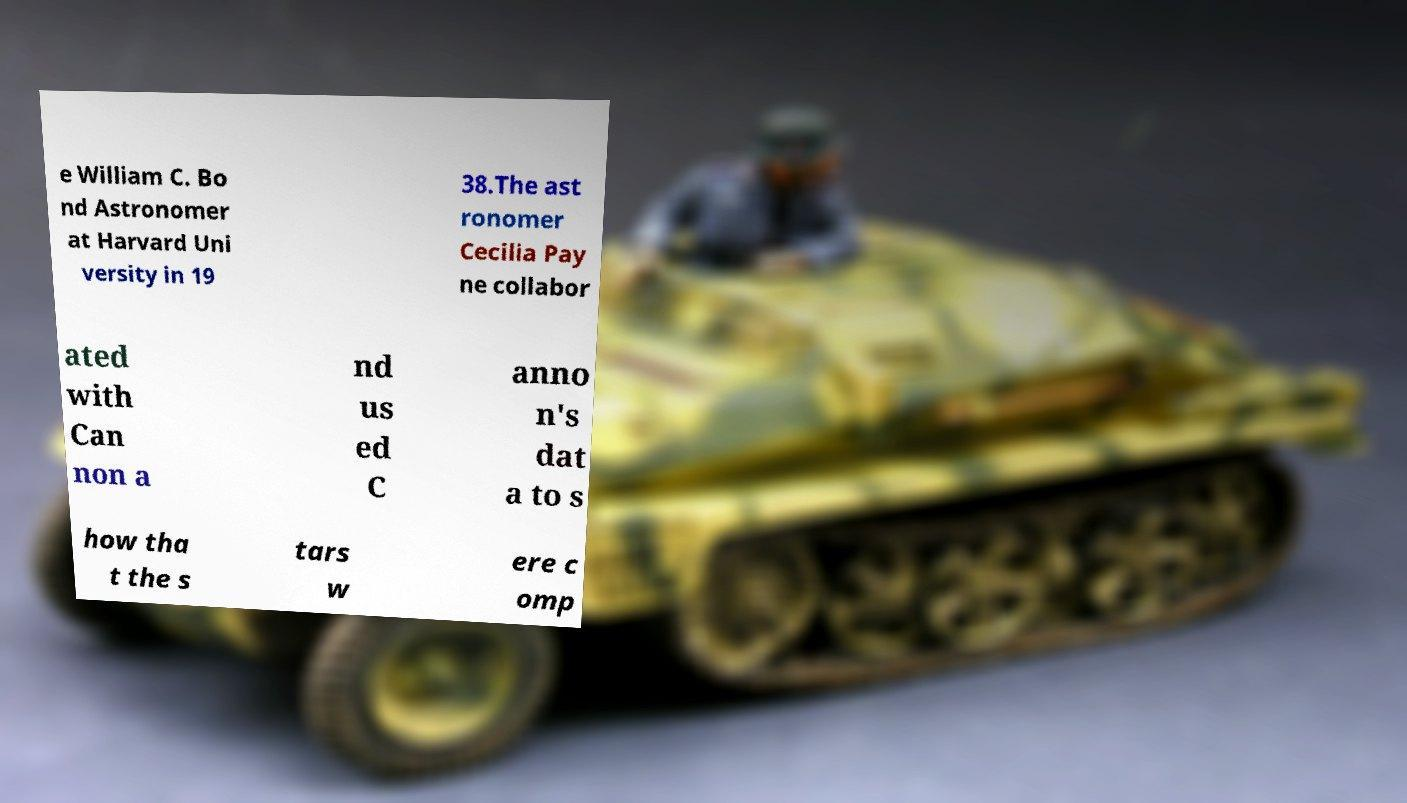Could you extract and type out the text from this image? e William C. Bo nd Astronomer at Harvard Uni versity in 19 38.The ast ronomer Cecilia Pay ne collabor ated with Can non a nd us ed C anno n's dat a to s how tha t the s tars w ere c omp 